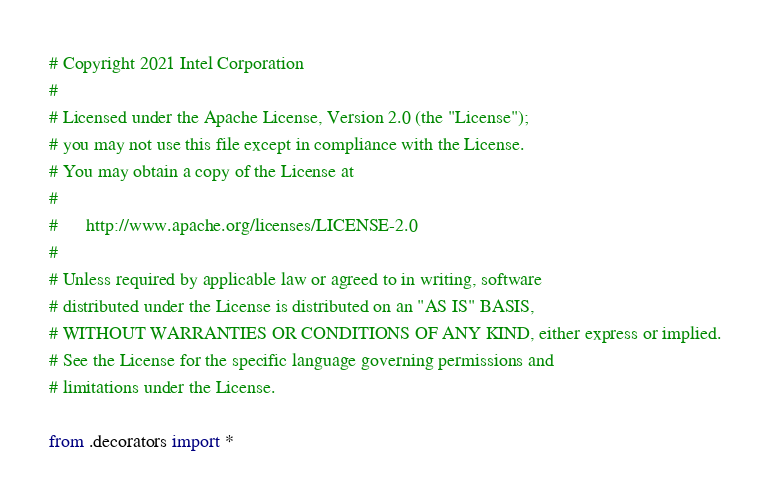Convert code to text. <code><loc_0><loc_0><loc_500><loc_500><_Python_># Copyright 2021 Intel Corporation
#
# Licensed under the Apache License, Version 2.0 (the "License");
# you may not use this file except in compliance with the License.
# You may obtain a copy of the License at
#
#      http://www.apache.org/licenses/LICENSE-2.0
#
# Unless required by applicable law or agreed to in writing, software
# distributed under the License is distributed on an "AS IS" BASIS,
# WITHOUT WARRANTIES OR CONDITIONS OF ANY KIND, either express or implied.
# See the License for the specific language governing permissions and
# limitations under the License.

from .decorators import *
</code> 